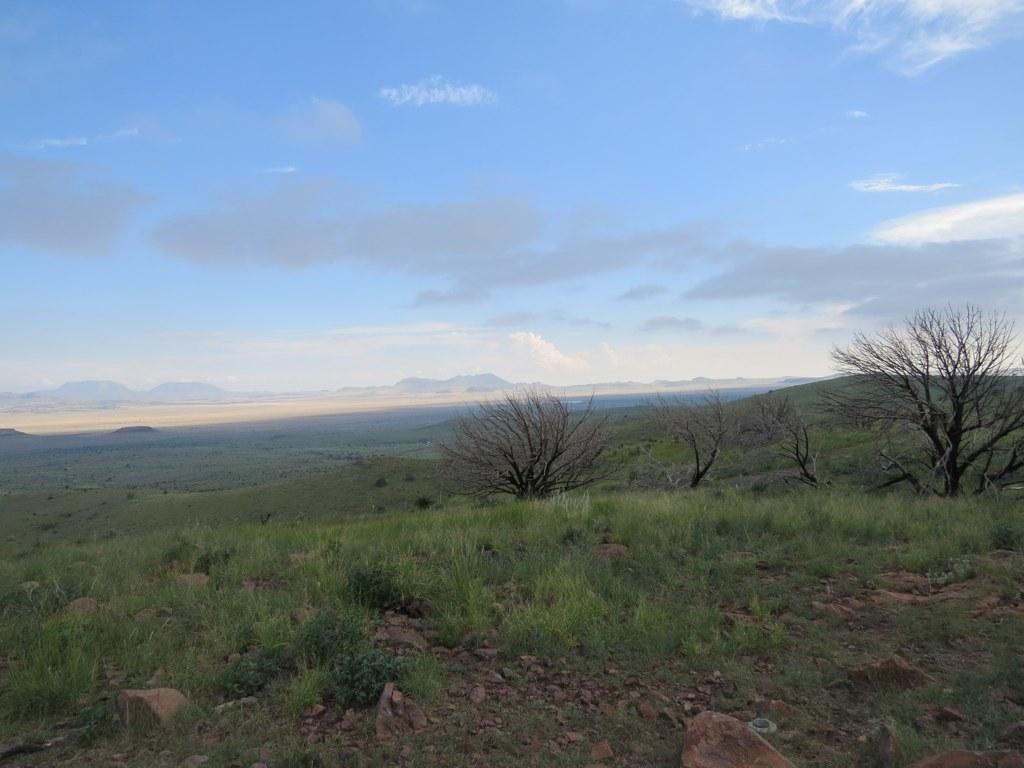What type of terrain is visible at the bottom of the image? There is grass and stones at the bottom of the image. What can be seen in the background of the image? There are mountains, trees, the sky, and clouds in the background of the image. What type of trousers can be seen hanging on the trees in the image? There are no trousers present in the image; it features grass, stones, mountains, trees, the sky, and clouds. Can you hear the sound of the seashore in the image? There is no sound present in the image, as it is a static visual representation. 